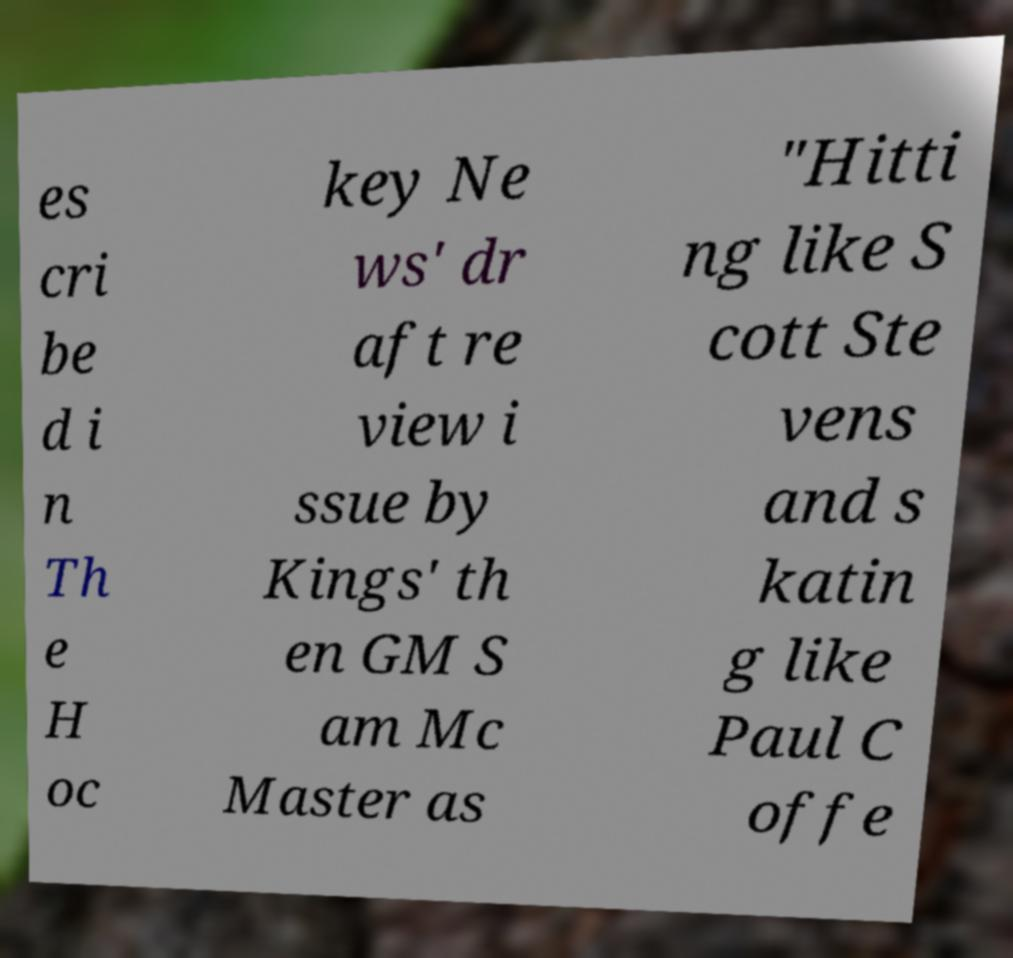Please read and relay the text visible in this image. What does it say? es cri be d i n Th e H oc key Ne ws' dr aft re view i ssue by Kings' th en GM S am Mc Master as "Hitti ng like S cott Ste vens and s katin g like Paul C offe 